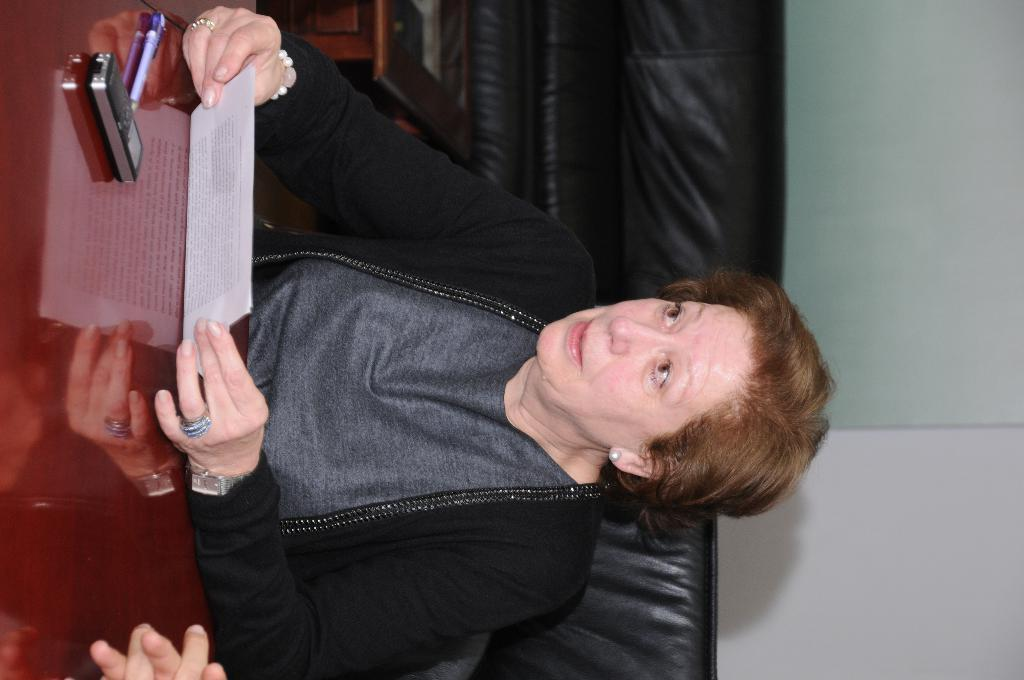What type of furniture is in the image? There is a sofa in the image. Who is present in the image? There is a person in the image. What is the person holding? The person is holding a paper. What other piece of furniture is in the image? There is a table in the image. What objects are on the table? There is a mobile phone and a pen on the table. What type of theory is the person discussing with the bed in the image? There is no bed present in the image, and no discussion about any theory is taking place. What color is the key on the table in the image? There is no key present on the table or in the image. 